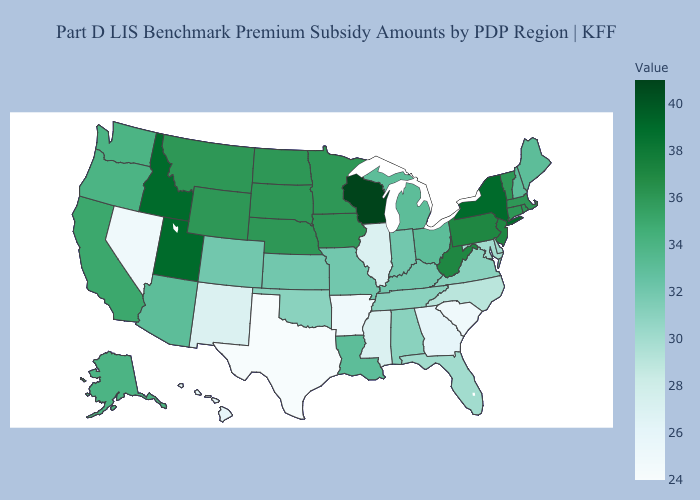Does the map have missing data?
Short answer required. No. Does Montana have a lower value than Oklahoma?
Quick response, please. No. Is the legend a continuous bar?
Keep it brief. Yes. Which states have the lowest value in the USA?
Give a very brief answer. Texas. Does New Mexico have the lowest value in the West?
Concise answer only. No. Does the map have missing data?
Answer briefly. No. 